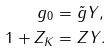Convert formula to latex. <formula><loc_0><loc_0><loc_500><loc_500>g _ { 0 } & = \tilde { g } Y , \\ 1 + Z _ { K } & = Z Y .</formula> 